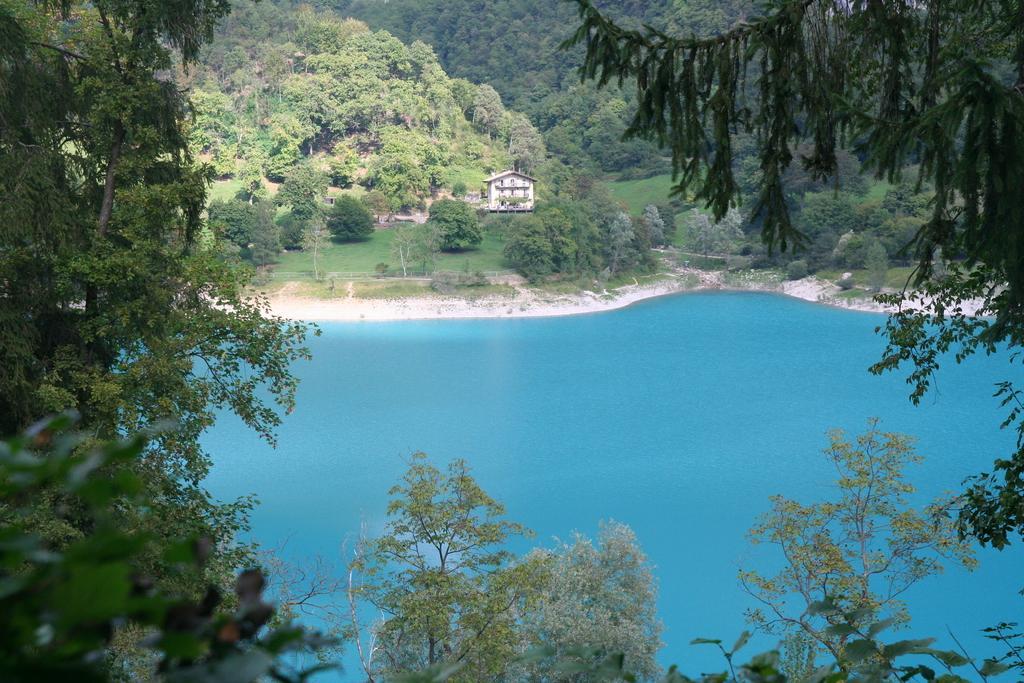Could you give a brief overview of what you see in this image? In this image we can see some trees and we can see the water and there is a house in the background. 